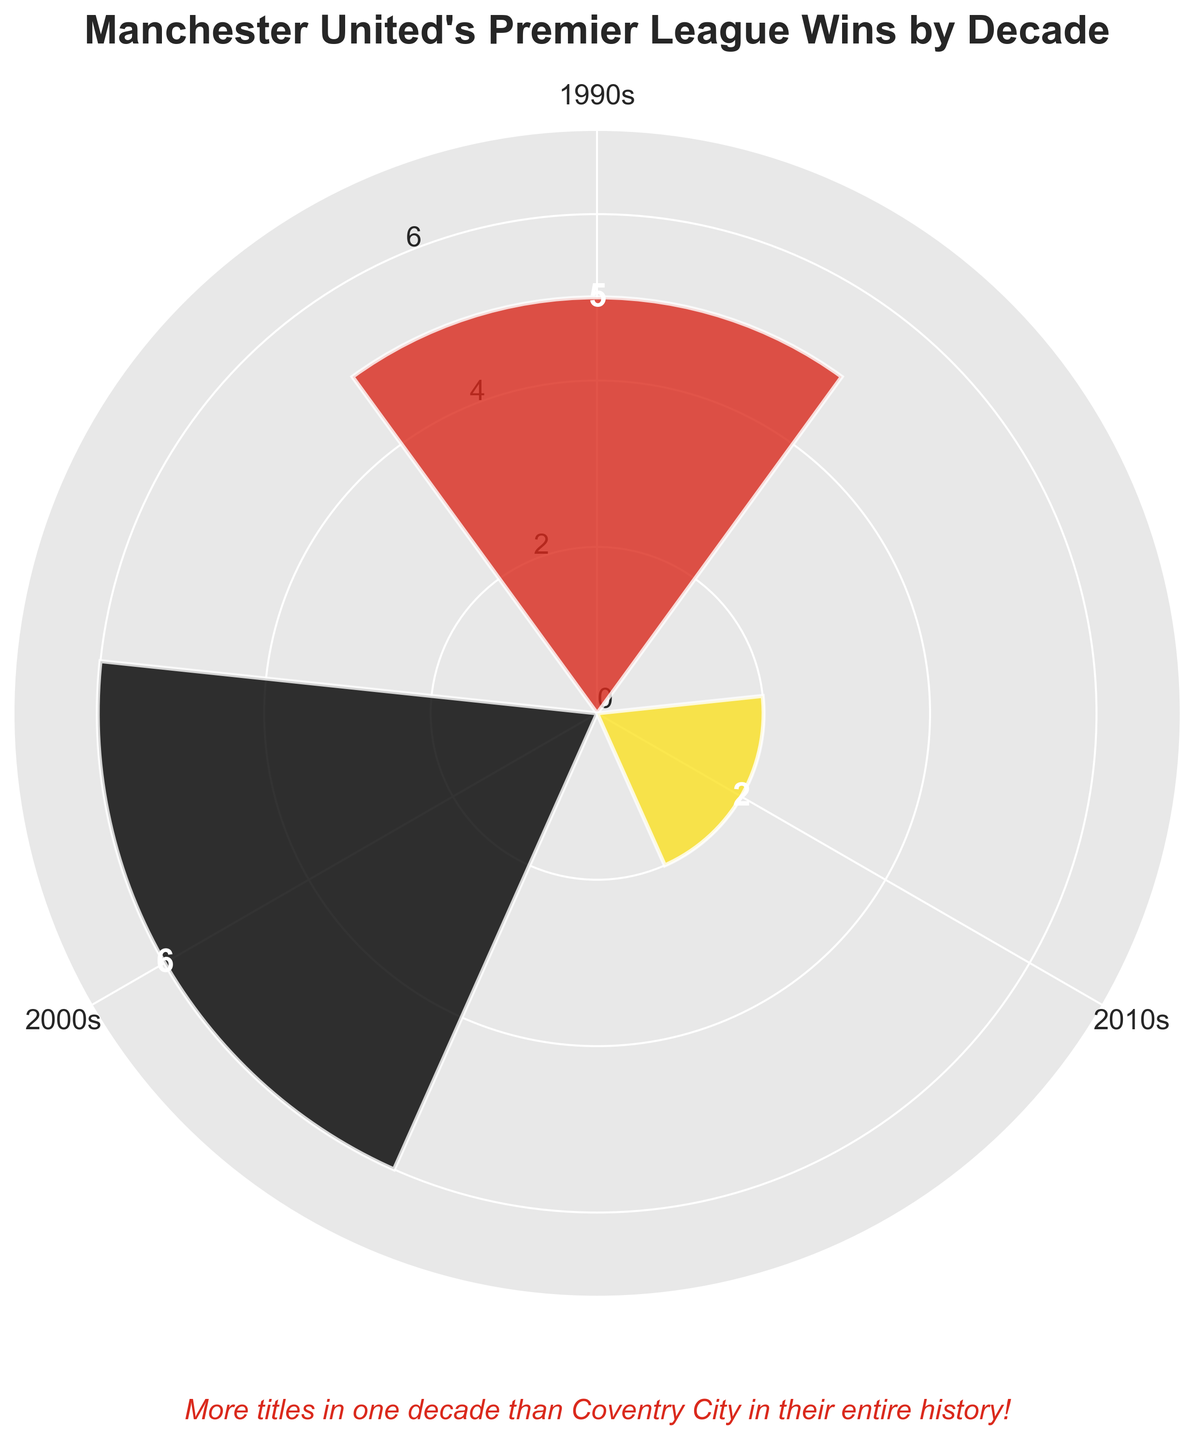what is the title of the rose chart? The title of the rose chart is typically found at the top of the figure. In this case, it states "Manchester United's Premier League Wins by Decade".
Answer: Manchester United's Premier League Wins by Decade which decade has the most Premier League wins? By observing the lengths of the bars, we see that the longest bar represents the 2000s decade. This indicates that the 2000s had the most wins.
Answer: 2000s how many more titles did Manchester United win in the 1990s compared to the 2010s? The 'Wins' values for the 1990s and 2010s are provided as 5 and 2 respectively. The difference is found by subtracting the two: 5 - 2 = 3.
Answer: 3 what is the combined number of Premier League titles won by Manchester United in the 1990s and 2000s? Adding the wins from the 1990s and 2000s gives us 5 + 6 = 11.
Answer: 11 which segment is represented in red color? The colors of the bars are red, black, and yellow respectively. Observing the figure, the red color corresponds to the first segment, which is labeled as the 1990s.
Answer: 1990s what is the average number of Premier League titles won per decade, based on the data provided? Sum the total wins (5 + 6 + 2 = 13) and divide by the number of decades (3). The average is 13 / 3 ≈ 4.33.
Answer: 4.33 how does the number of titles won in the 2010s compare to the 2000s? The figure shows 2 titles in the 2010s and 6 in the 2000s. Comparing them, 2 is less than 6.
Answer: less what is the range of Premier League titles won per decade? The range is calculated as the difference between the maximum and minimum values of wins per decade. Here, the maximum is 6 and the minimum is 2, thus the range is 6 - 2 = 4.
Answer: 4 in which decade did Manchester United win more than twice the titles compared to the 2010s? The 2010s had 2 titles. More than twice means more than 4 titles. The 1990s had 5, and the 2000s had 6, both of which are greater than 4.
Answer: 1990s and 2000s 